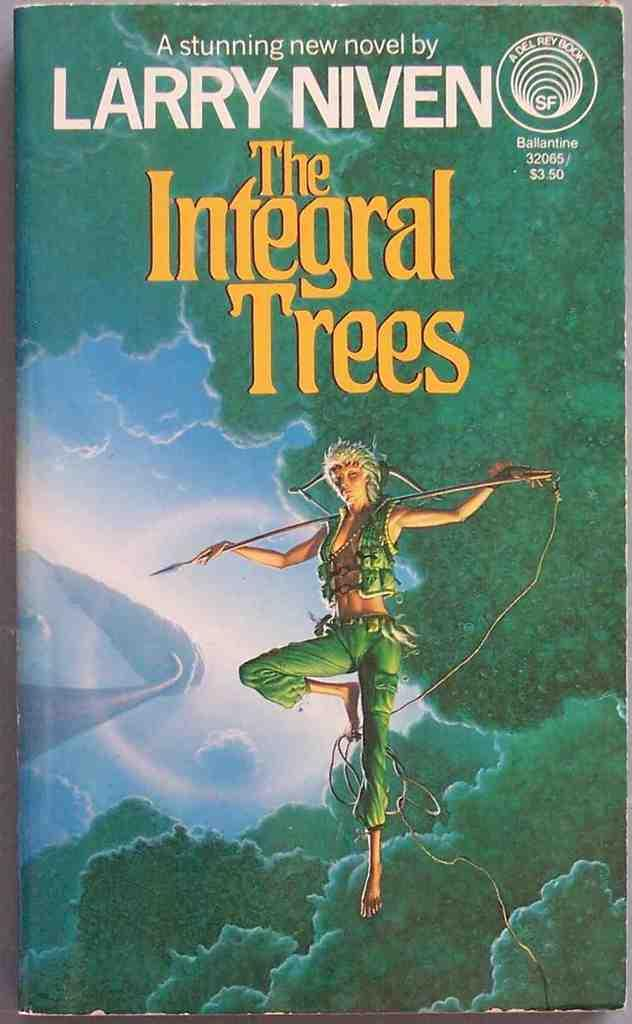<image>
Relay a brief, clear account of the picture shown. A Larry Niven novel shows a floating woman with a bow and arrow on the cover. 